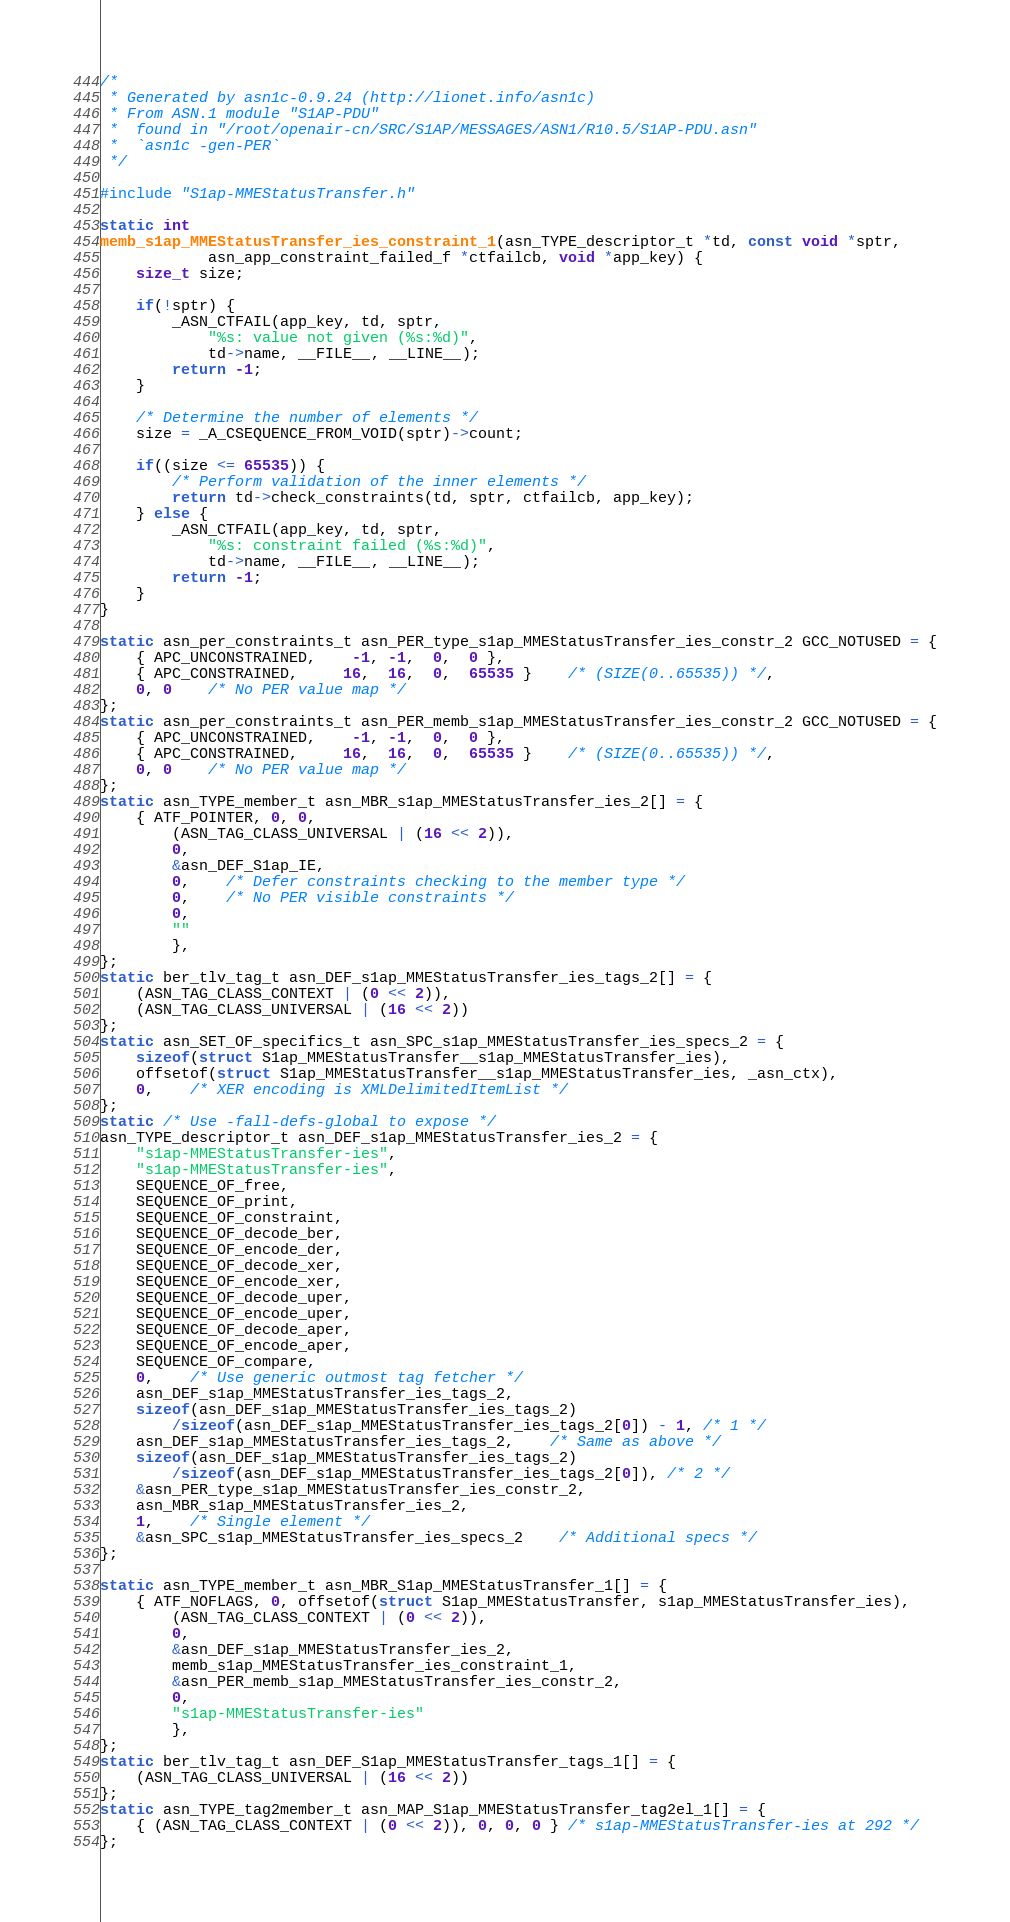Convert code to text. <code><loc_0><loc_0><loc_500><loc_500><_C_>/*
 * Generated by asn1c-0.9.24 (http://lionet.info/asn1c)
 * From ASN.1 module "S1AP-PDU"
 * 	found in "/root/openair-cn/SRC/S1AP/MESSAGES/ASN1/R10.5/S1AP-PDU.asn"
 * 	`asn1c -gen-PER`
 */

#include "S1ap-MMEStatusTransfer.h"

static int
memb_s1ap_MMEStatusTransfer_ies_constraint_1(asn_TYPE_descriptor_t *td, const void *sptr,
			asn_app_constraint_failed_f *ctfailcb, void *app_key) {
	size_t size;
	
	if(!sptr) {
		_ASN_CTFAIL(app_key, td, sptr,
			"%s: value not given (%s:%d)",
			td->name, __FILE__, __LINE__);
		return -1;
	}
	
	/* Determine the number of elements */
	size = _A_CSEQUENCE_FROM_VOID(sptr)->count;
	
	if((size <= 65535)) {
		/* Perform validation of the inner elements */
		return td->check_constraints(td, sptr, ctfailcb, app_key);
	} else {
		_ASN_CTFAIL(app_key, td, sptr,
			"%s: constraint failed (%s:%d)",
			td->name, __FILE__, __LINE__);
		return -1;
	}
}

static asn_per_constraints_t asn_PER_type_s1ap_MMEStatusTransfer_ies_constr_2 GCC_NOTUSED = {
	{ APC_UNCONSTRAINED,	-1, -1,  0,  0 },
	{ APC_CONSTRAINED,	 16,  16,  0,  65535 }	/* (SIZE(0..65535)) */,
	0, 0	/* No PER value map */
};
static asn_per_constraints_t asn_PER_memb_s1ap_MMEStatusTransfer_ies_constr_2 GCC_NOTUSED = {
	{ APC_UNCONSTRAINED,	-1, -1,  0,  0 },
	{ APC_CONSTRAINED,	 16,  16,  0,  65535 }	/* (SIZE(0..65535)) */,
	0, 0	/* No PER value map */
};
static asn_TYPE_member_t asn_MBR_s1ap_MMEStatusTransfer_ies_2[] = {
	{ ATF_POINTER, 0, 0,
		(ASN_TAG_CLASS_UNIVERSAL | (16 << 2)),
		0,
		&asn_DEF_S1ap_IE,
		0,	/* Defer constraints checking to the member type */
		0,	/* No PER visible constraints */
		0,
		""
		},
};
static ber_tlv_tag_t asn_DEF_s1ap_MMEStatusTransfer_ies_tags_2[] = {
	(ASN_TAG_CLASS_CONTEXT | (0 << 2)),
	(ASN_TAG_CLASS_UNIVERSAL | (16 << 2))
};
static asn_SET_OF_specifics_t asn_SPC_s1ap_MMEStatusTransfer_ies_specs_2 = {
	sizeof(struct S1ap_MMEStatusTransfer__s1ap_MMEStatusTransfer_ies),
	offsetof(struct S1ap_MMEStatusTransfer__s1ap_MMEStatusTransfer_ies, _asn_ctx),
	0,	/* XER encoding is XMLDelimitedItemList */
};
static /* Use -fall-defs-global to expose */
asn_TYPE_descriptor_t asn_DEF_s1ap_MMEStatusTransfer_ies_2 = {
	"s1ap-MMEStatusTransfer-ies",
	"s1ap-MMEStatusTransfer-ies",
	SEQUENCE_OF_free,
	SEQUENCE_OF_print,
	SEQUENCE_OF_constraint,
	SEQUENCE_OF_decode_ber,
	SEQUENCE_OF_encode_der,
	SEQUENCE_OF_decode_xer,
	SEQUENCE_OF_encode_xer,
	SEQUENCE_OF_decode_uper,
	SEQUENCE_OF_encode_uper,
	SEQUENCE_OF_decode_aper,
	SEQUENCE_OF_encode_aper,
	SEQUENCE_OF_compare,
	0,	/* Use generic outmost tag fetcher */
	asn_DEF_s1ap_MMEStatusTransfer_ies_tags_2,
	sizeof(asn_DEF_s1ap_MMEStatusTransfer_ies_tags_2)
		/sizeof(asn_DEF_s1ap_MMEStatusTransfer_ies_tags_2[0]) - 1, /* 1 */
	asn_DEF_s1ap_MMEStatusTransfer_ies_tags_2,	/* Same as above */
	sizeof(asn_DEF_s1ap_MMEStatusTransfer_ies_tags_2)
		/sizeof(asn_DEF_s1ap_MMEStatusTransfer_ies_tags_2[0]), /* 2 */
	&asn_PER_type_s1ap_MMEStatusTransfer_ies_constr_2,
	asn_MBR_s1ap_MMEStatusTransfer_ies_2,
	1,	/* Single element */
	&asn_SPC_s1ap_MMEStatusTransfer_ies_specs_2	/* Additional specs */
};

static asn_TYPE_member_t asn_MBR_S1ap_MMEStatusTransfer_1[] = {
	{ ATF_NOFLAGS, 0, offsetof(struct S1ap_MMEStatusTransfer, s1ap_MMEStatusTransfer_ies),
		(ASN_TAG_CLASS_CONTEXT | (0 << 2)),
		0,
		&asn_DEF_s1ap_MMEStatusTransfer_ies_2,
		memb_s1ap_MMEStatusTransfer_ies_constraint_1,
		&asn_PER_memb_s1ap_MMEStatusTransfer_ies_constr_2,
		0,
		"s1ap-MMEStatusTransfer-ies"
		},
};
static ber_tlv_tag_t asn_DEF_S1ap_MMEStatusTransfer_tags_1[] = {
	(ASN_TAG_CLASS_UNIVERSAL | (16 << 2))
};
static asn_TYPE_tag2member_t asn_MAP_S1ap_MMEStatusTransfer_tag2el_1[] = {
    { (ASN_TAG_CLASS_CONTEXT | (0 << 2)), 0, 0, 0 } /* s1ap-MMEStatusTransfer-ies at 292 */
};</code> 